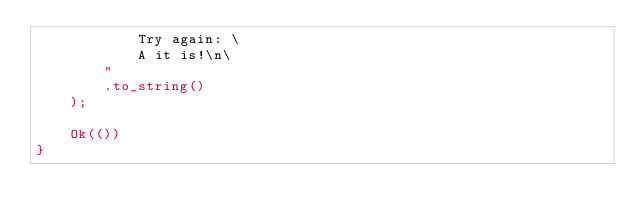<code> <loc_0><loc_0><loc_500><loc_500><_Rust_>            Try again: \
            A it is!\n\
        "
        .to_string()
    );

    Ok(())
}
</code> 